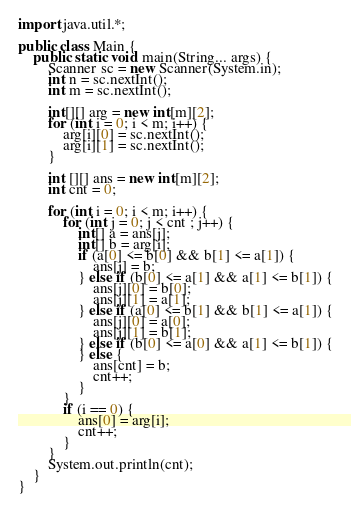<code> <loc_0><loc_0><loc_500><loc_500><_Java_>import java.util.*;

public class Main {
    public static void main(String... args) {
        Scanner sc = new Scanner(System.in);
        int n = sc.nextInt();
        int m = sc.nextInt();

        int[][] arg = new int[m][2];
        for (int i = 0; i < m; i++) {
            arg[i][0] = sc.nextInt();
            arg[i][1] = sc.nextInt();
        }

        int [][] ans = new int[m][2];
        int cnt = 0;

        for (int i = 0; i < m; i++) {
            for (int j = 0; j < cnt ; j++) {
                int[] a = ans[j];
                int[] b = arg[i];
                if (a[0] <= b[0] && b[1] <= a[1]) {
                    ans[j] = b;
                } else if (b[0] <= a[1] && a[1] <= b[1]) {
                    ans[j][0] = b[0];
                    ans[j][1] = a[1];
                } else if (a[0] <= b[1] && b[1] <= a[1]) {
                    ans[j][0] = a[0];
                    ans[j][1] = b[1];
                } else if (b[0] <= a[0] && a[1] <= b[1]) {
                } else {
                    ans[cnt] = b;
                    cnt++;
                }
            }
            if (i == 0) {
                ans[0] = arg[i];
                cnt++;
            }
        }
        System.out.println(cnt);
    }
}</code> 